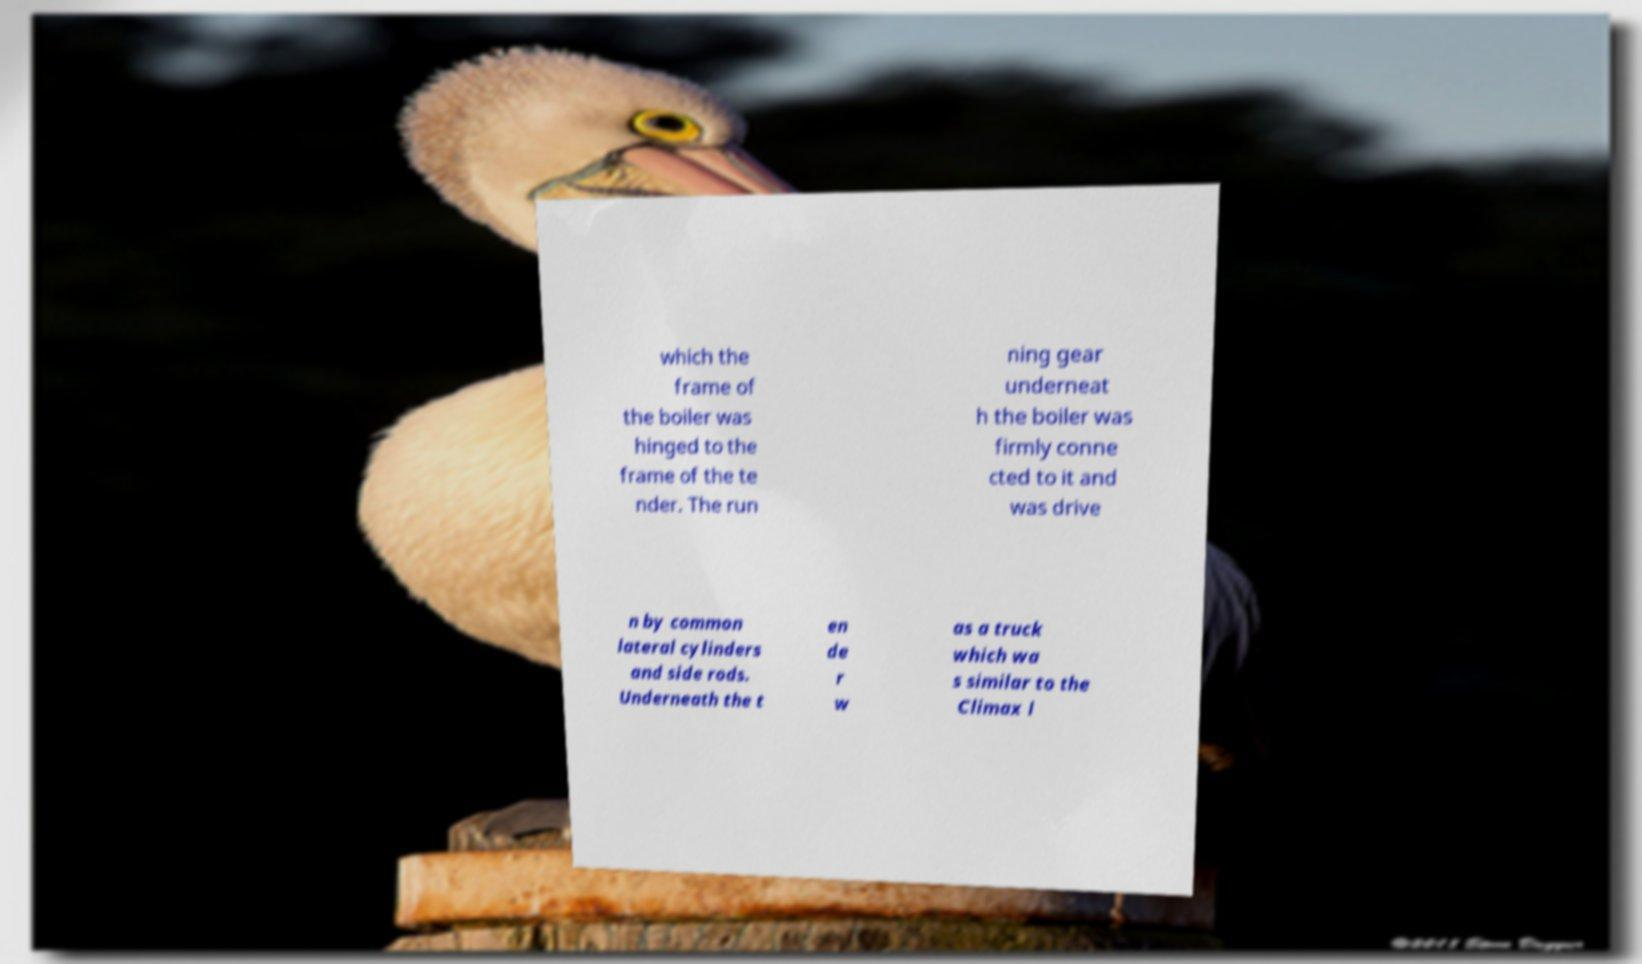For documentation purposes, I need the text within this image transcribed. Could you provide that? which the frame of the boiler was hinged to the frame of the te nder. The run ning gear underneat h the boiler was firmly conne cted to it and was drive n by common lateral cylinders and side rods. Underneath the t en de r w as a truck which wa s similar to the Climax l 